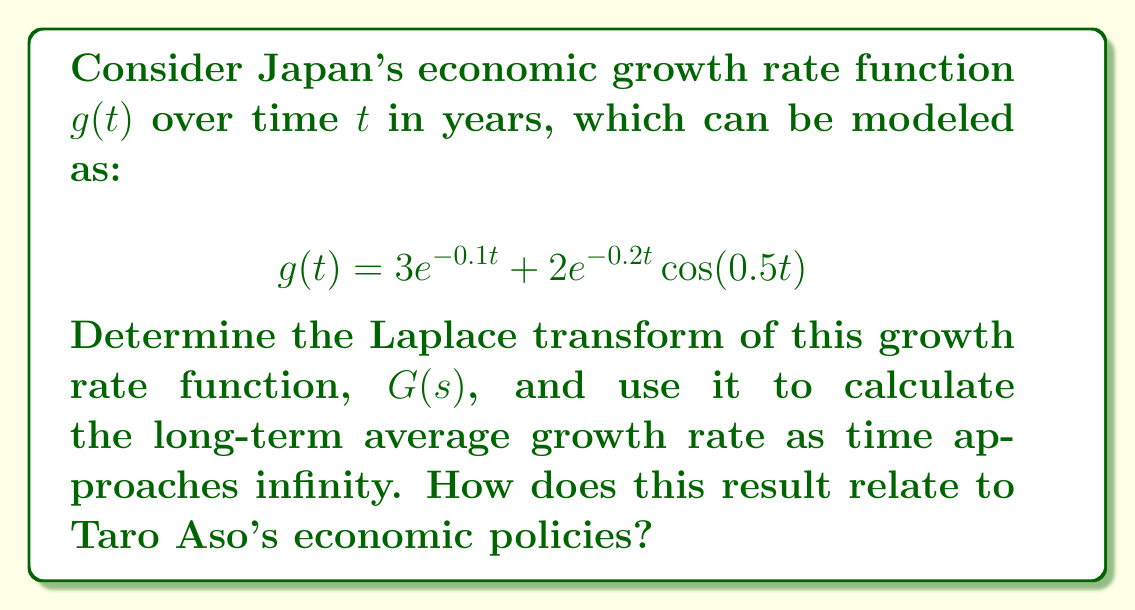What is the answer to this math problem? Let's approach this problem step by step:

1) The Laplace transform of $g(t)$ is given by:

   $$G(s) = \mathcal{L}\{g(t)\} = \int_0^\infty g(t)e^{-st}dt$$

2) We need to find the Laplace transform of each term separately:

   For $3e^{-0.1t}$:
   $$\mathcal{L}\{3e^{-0.1t}\} = \frac{3}{s+0.1}$$

   For $2e^{-0.2t}\cos(0.5t)$:
   $$\mathcal{L}\{2e^{-0.2t}\cos(0.5t)\} = 2\cdot\frac{s+0.2}{(s+0.2)^2+0.5^2}$$

3) Adding these together:

   $$G(s) = \frac{3}{s+0.1} + 2\cdot\frac{s+0.2}{(s+0.2)^2+0.5^2}$$

4) To find the long-term average growth rate, we use the Final Value Theorem:

   $$\lim_{t\to\infty} g(t) = \lim_{s\to0} sG(s)$$

5) Applying this to our $G(s)$:

   $$\lim_{s\to0} s\left(\frac{3}{s+0.1} + 2\cdot\frac{s+0.2}{(s+0.2)^2+0.5^2}\right)$$

6) As $s$ approaches 0, the second term approaches 0 faster than the first term. So:

   $$\lim_{s\to0} s\left(\frac{3}{s+0.1}\right) = \lim_{s\to0} \frac{3s}{s+0.1} = 0$$

7) Therefore, the long-term average growth rate approaches 0.

This result suggests that, according to this model, Japan's economic growth rate will eventually stabilize around 0% in the long run. This relates to Taro Aso's economic policies, which have often focused on stimulating short-term growth through fiscal spending. However, the model indicates that such policies may not lead to sustained long-term growth without structural reforms.
Answer: The Laplace transform of the growth rate function is:

$$G(s) = \frac{3}{s+0.1} + 2\cdot\frac{s+0.2}{(s+0.2)^2+0.5^2}$$

The long-term average growth rate as time approaches infinity is 0%. 